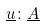Convert formula to latex. <formula><loc_0><loc_0><loc_500><loc_500>\underline { u } \colon \underline { A }</formula> 